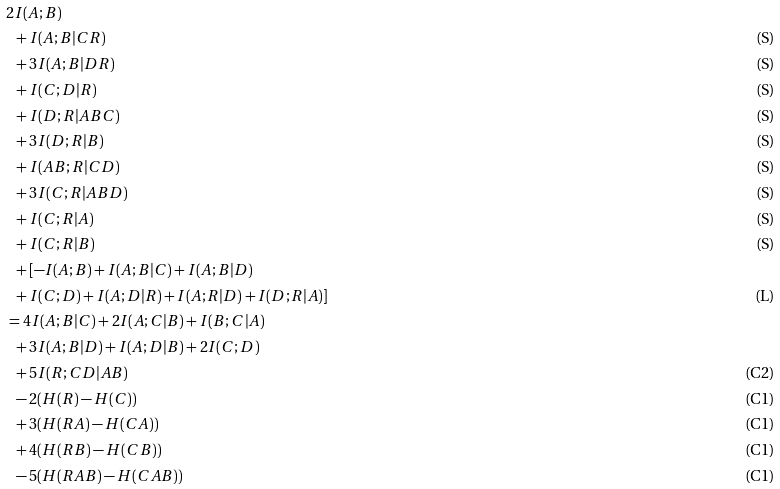Convert formula to latex. <formula><loc_0><loc_0><loc_500><loc_500>& 2 I ( A ; B ) & \\ & \ \ + I ( A ; B | C R ) & \text {(S)} \\ & \ \ + 3 I ( A ; B | D R ) & \text {(S)} \\ & \ \ + I ( C ; D | R ) & \text {(S)} \\ & \ \ + I ( D ; R | A B C ) & \text {(S)} \\ & \ \ + 3 I ( D ; R | B ) & \text {(S)} \\ & \ \ + I ( A B ; R | C D ) & \text {(S)} \\ & \ \ + 3 I ( C ; R | A B D ) & \text {(S)} \\ & \ \ + I ( C ; R | A ) & \text {(S)} \\ & \ \ + I ( C ; R | B ) & \text {(S)} \\ & \ \ + [ - I ( A ; B ) + I ( A ; B | C ) + I ( A ; B | D ) & \\ & \ \ + I ( C ; D ) + I ( A ; D | R ) + I ( A ; R | D ) + I ( D ; R | A ) ] & \text {(L)} \\ & = 4 I ( A ; B | C ) + 2 I ( A ; C | B ) + I ( B ; C | A ) \\ & \ \ + 3 I ( A ; B | D ) + I ( A ; D | B ) + 2 I ( C ; D ) \\ & \ \ + 5 I ( R ; C D | A B ) & \text {(C2)} \\ & \ \ - 2 ( H ( R ) - H ( C ) ) & \text {(C1)} \\ & \ \ + 3 ( H ( R A ) - H ( C A ) ) & \text {(C1)} \\ & \ \ + 4 ( H ( R B ) - H ( C B ) ) & \text {(C1)} \\ & \ \ - 5 ( H ( R A B ) - H ( C A B ) ) & \text {(C1)} \\</formula> 